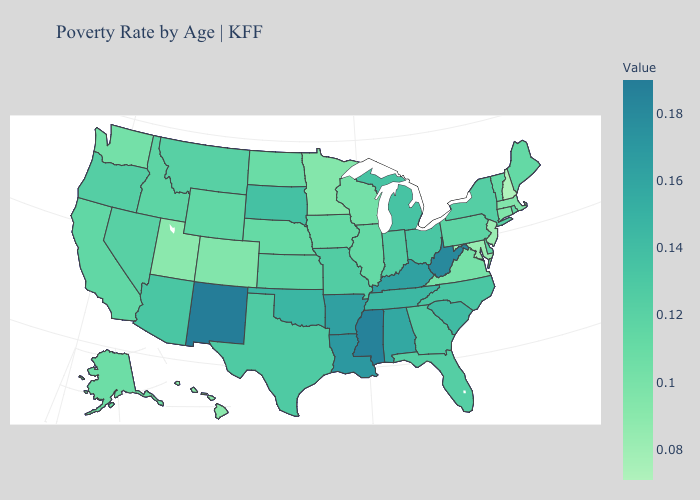Which states have the lowest value in the South?
Quick response, please. Maryland. Does New Hampshire have the lowest value in the USA?
Keep it brief. Yes. Which states have the lowest value in the South?
Quick response, please. Maryland. Is the legend a continuous bar?
Give a very brief answer. Yes. Is the legend a continuous bar?
Answer briefly. Yes. 